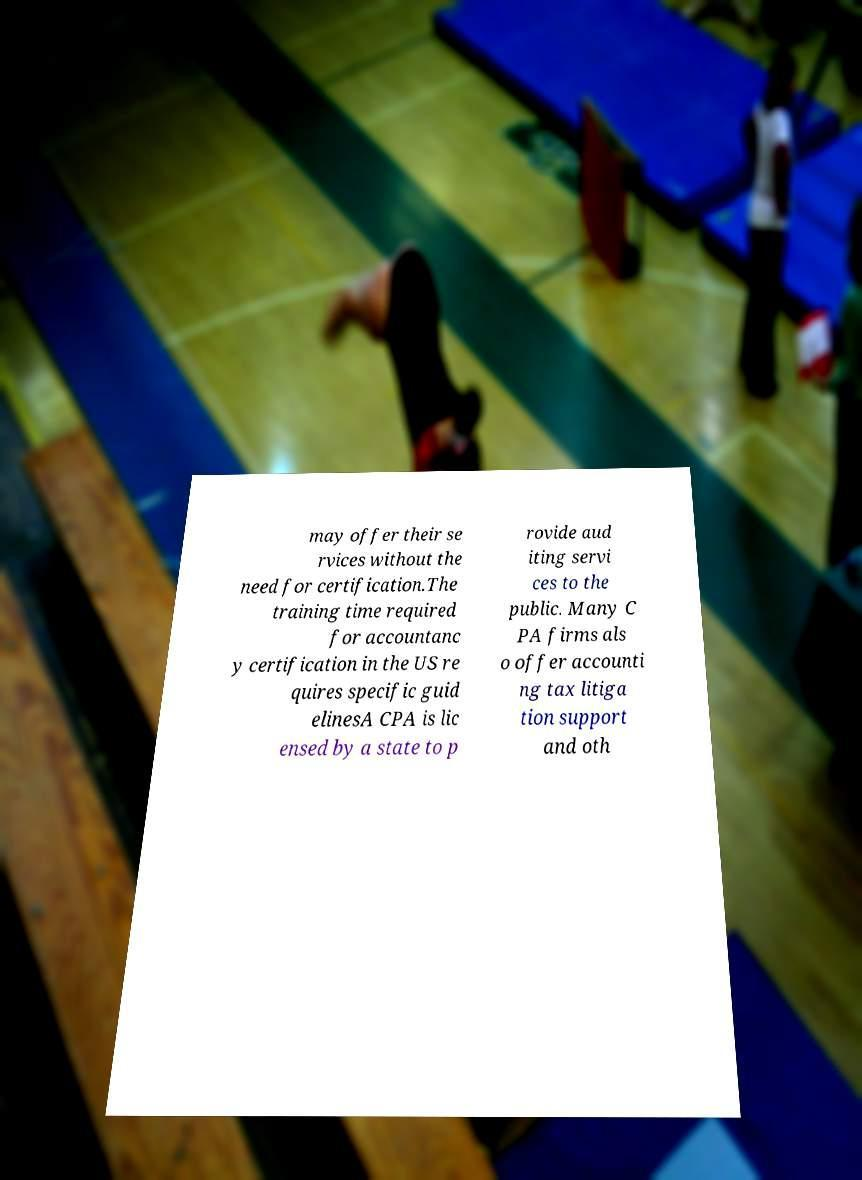Could you assist in decoding the text presented in this image and type it out clearly? may offer their se rvices without the need for certification.The training time required for accountanc y certification in the US re quires specific guid elinesA CPA is lic ensed by a state to p rovide aud iting servi ces to the public. Many C PA firms als o offer accounti ng tax litiga tion support and oth 